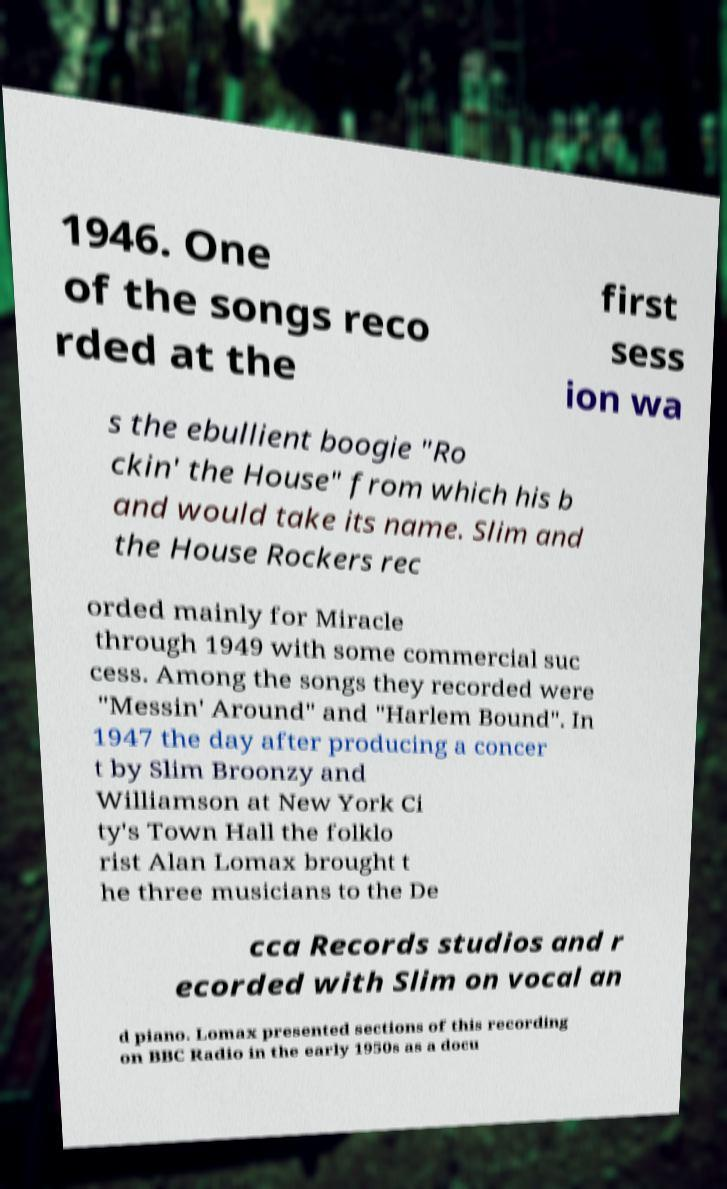Please read and relay the text visible in this image. What does it say? 1946. One of the songs reco rded at the first sess ion wa s the ebullient boogie "Ro ckin' the House" from which his b and would take its name. Slim and the House Rockers rec orded mainly for Miracle through 1949 with some commercial suc cess. Among the songs they recorded were "Messin' Around" and "Harlem Bound". In 1947 the day after producing a concer t by Slim Broonzy and Williamson at New York Ci ty's Town Hall the folklo rist Alan Lomax brought t he three musicians to the De cca Records studios and r ecorded with Slim on vocal an d piano. Lomax presented sections of this recording on BBC Radio in the early 1950s as a docu 